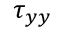<formula> <loc_0><loc_0><loc_500><loc_500>\tau _ { y y }</formula> 